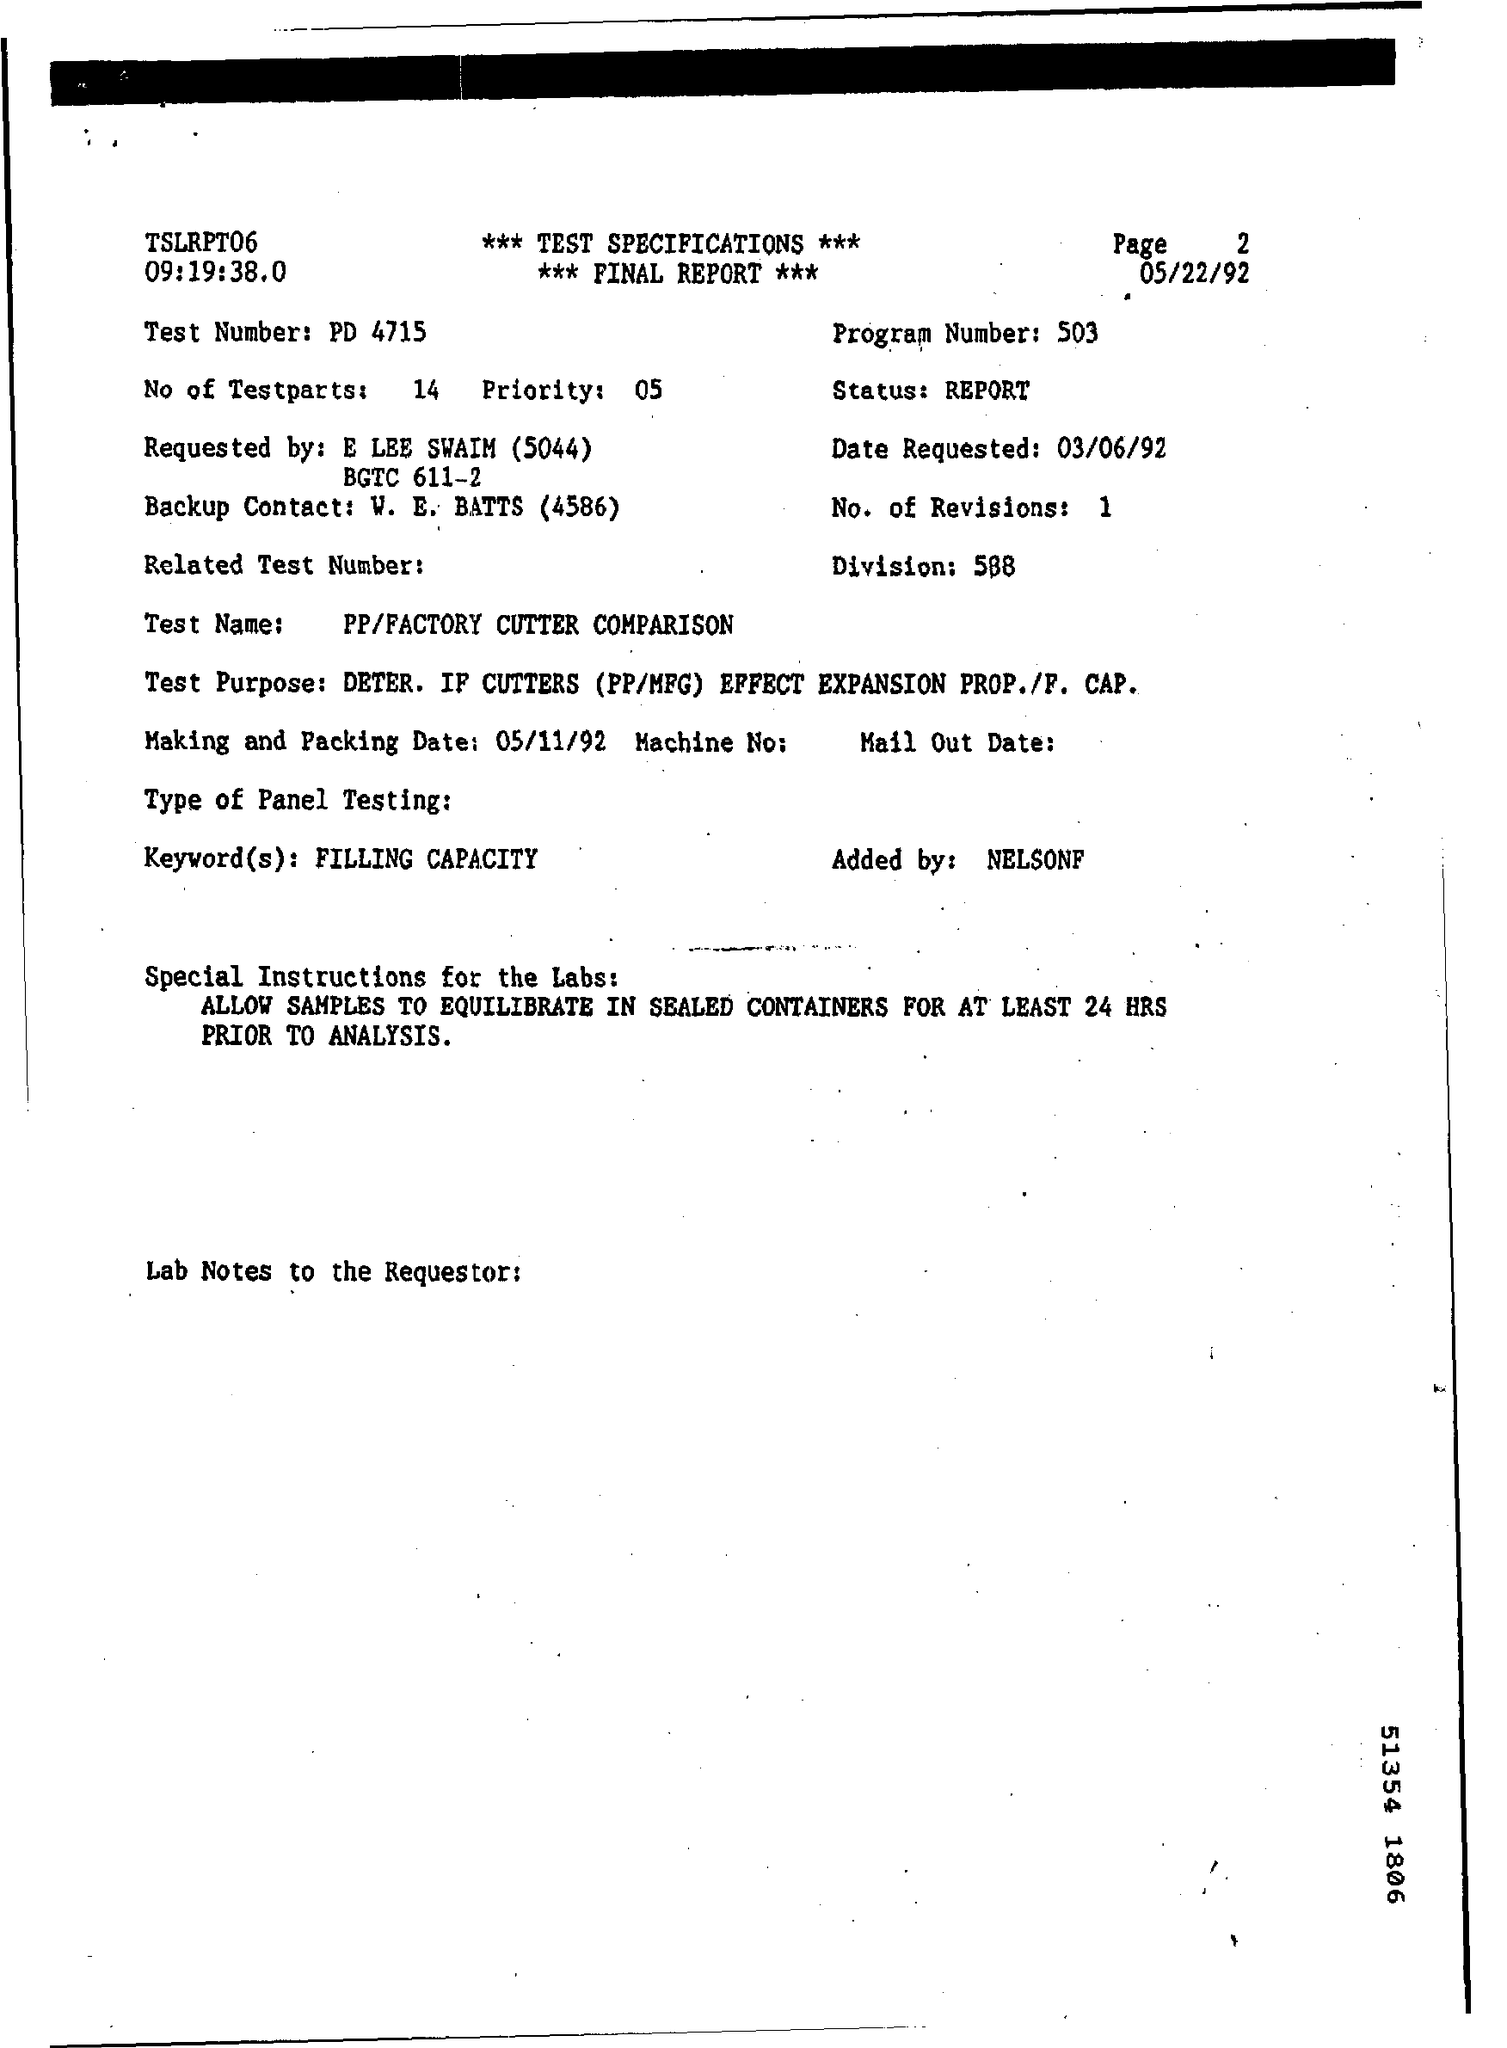Indicate a few pertinent items in this graphic. This request is made by E LEE SWAIM (5044). The date requested is March 6, 1992. What is the program number? 503.. I have made one to one thousand revisions. On May 11, 1992, the making and packing date for a particular item was recorded. 